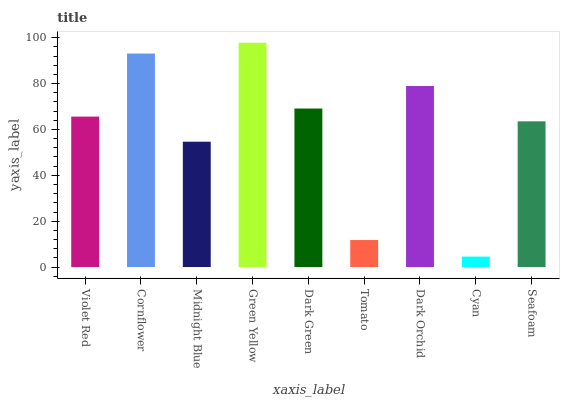Is Cyan the minimum?
Answer yes or no. Yes. Is Green Yellow the maximum?
Answer yes or no. Yes. Is Cornflower the minimum?
Answer yes or no. No. Is Cornflower the maximum?
Answer yes or no. No. Is Cornflower greater than Violet Red?
Answer yes or no. Yes. Is Violet Red less than Cornflower?
Answer yes or no. Yes. Is Violet Red greater than Cornflower?
Answer yes or no. No. Is Cornflower less than Violet Red?
Answer yes or no. No. Is Violet Red the high median?
Answer yes or no. Yes. Is Violet Red the low median?
Answer yes or no. Yes. Is Cornflower the high median?
Answer yes or no. No. Is Cornflower the low median?
Answer yes or no. No. 